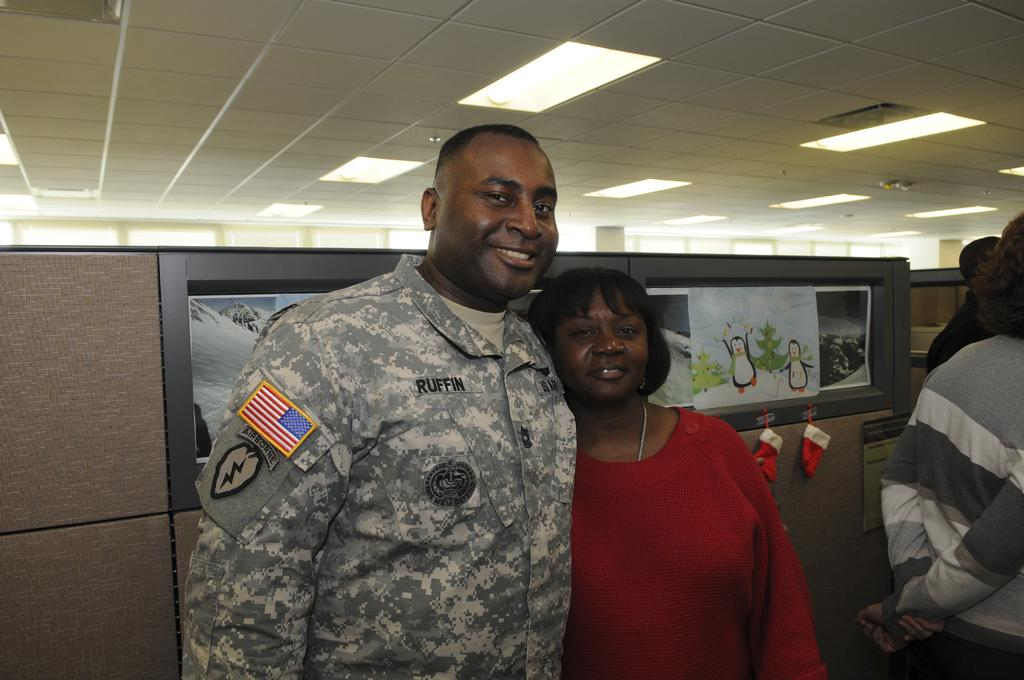How many people are present in the image? There are two people, a man and a woman, present in the image. What can be seen in the background of the image? There is a wall in the image, and posters are visible on the wall. What is above the people in the image? There is a ceiling in the image. What type of lighting is present in the image? There are lights in the image. What else can be seen in the image besides the people and the wall? There are objects in the image. Can you describe the people on the right side of the image? The people on the right side of the image are truncated, meaning they are partially cut off by the edge of the image. What rule is being enforced by the man in the image? There is no indication in the image that the man is enforcing any rule. What type of material is the woman using to lead the group in the image? There is no indication in the image that the woman is leading a group or using any material to do so. 